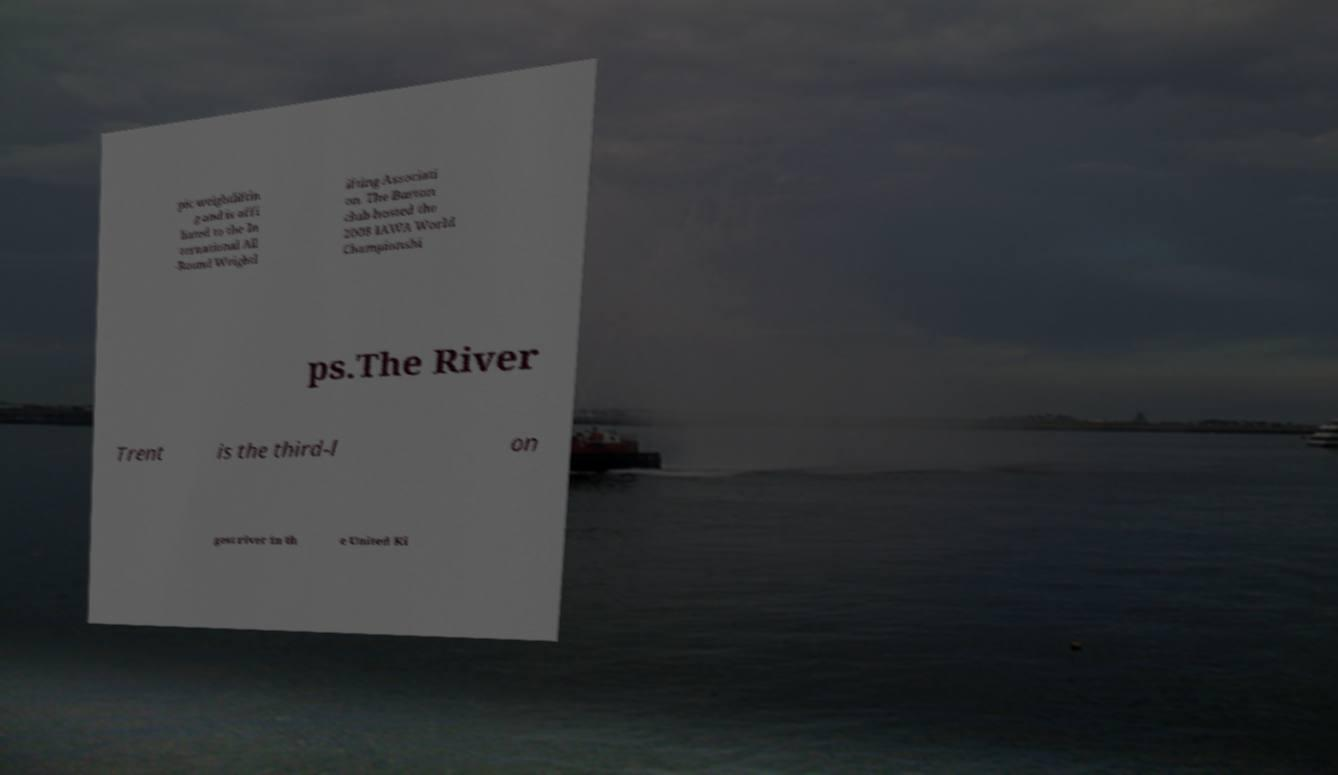What messages or text are displayed in this image? I need them in a readable, typed format. pic weightliftin g and is affi liated to the In ternational All -Round Weightl ifting Associati on. The Burton club hosted the 2008 IAWA World Championshi ps.The River Trent is the third-l on gest river in th e United Ki 